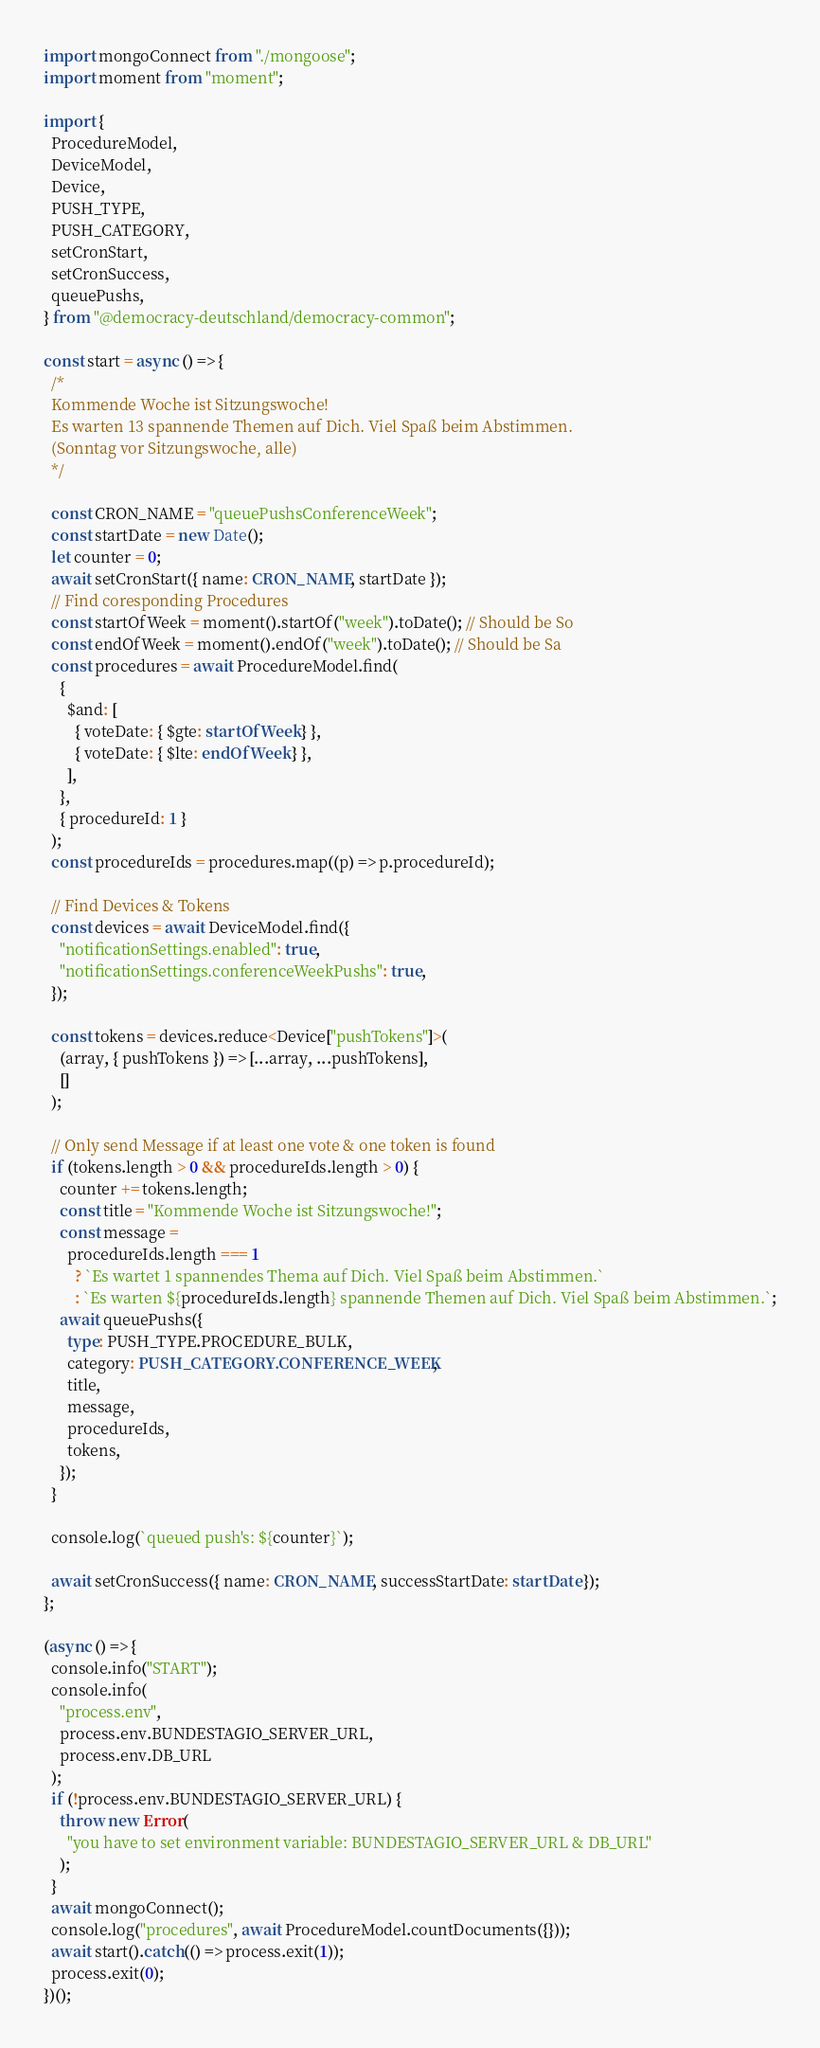<code> <loc_0><loc_0><loc_500><loc_500><_TypeScript_>import mongoConnect from "./mongoose";
import moment from "moment";

import {
  ProcedureModel,
  DeviceModel,
  Device,
  PUSH_TYPE,
  PUSH_CATEGORY,
  setCronStart,
  setCronSuccess,
  queuePushs,
} from "@democracy-deutschland/democracy-common";

const start = async () => {
  /*
  Kommende Woche ist Sitzungswoche!
  Es warten 13 spannende Themen auf Dich. Viel Spaß beim Abstimmen.
  (Sonntag vor Sitzungswoche, alle)
  */

  const CRON_NAME = "queuePushsConferenceWeek";
  const startDate = new Date();
  let counter = 0;
  await setCronStart({ name: CRON_NAME, startDate });
  // Find coresponding Procedures
  const startOfWeek = moment().startOf("week").toDate(); // Should be So
  const endOfWeek = moment().endOf("week").toDate(); // Should be Sa
  const procedures = await ProcedureModel.find(
    {
      $and: [
        { voteDate: { $gte: startOfWeek } },
        { voteDate: { $lte: endOfWeek } },
      ],
    },
    { procedureId: 1 }
  );
  const procedureIds = procedures.map((p) => p.procedureId);

  // Find Devices & Tokens
  const devices = await DeviceModel.find({
    "notificationSettings.enabled": true,
    "notificationSettings.conferenceWeekPushs": true,
  });

  const tokens = devices.reduce<Device["pushTokens"]>(
    (array, { pushTokens }) => [...array, ...pushTokens],
    []
  );

  // Only send Message if at least one vote & one token is found
  if (tokens.length > 0 && procedureIds.length > 0) {
    counter += tokens.length;
    const title = "Kommende Woche ist Sitzungswoche!";
    const message =
      procedureIds.length === 1
        ? `Es wartet 1 spannendes Thema auf Dich. Viel Spaß beim Abstimmen.`
        : `Es warten ${procedureIds.length} spannende Themen auf Dich. Viel Spaß beim Abstimmen.`;
    await queuePushs({
      type: PUSH_TYPE.PROCEDURE_BULK,
      category: PUSH_CATEGORY.CONFERENCE_WEEK,
      title,
      message,
      procedureIds,
      tokens,
    });
  }

  console.log(`queued push's: ${counter}`);

  await setCronSuccess({ name: CRON_NAME, successStartDate: startDate });
};

(async () => {
  console.info("START");
  console.info(
    "process.env",
    process.env.BUNDESTAGIO_SERVER_URL,
    process.env.DB_URL
  );
  if (!process.env.BUNDESTAGIO_SERVER_URL) {
    throw new Error(
      "you have to set environment variable: BUNDESTAGIO_SERVER_URL & DB_URL"
    );
  }
  await mongoConnect();
  console.log("procedures", await ProcedureModel.countDocuments({}));
  await start().catch(() => process.exit(1));
  process.exit(0);
})();
</code> 